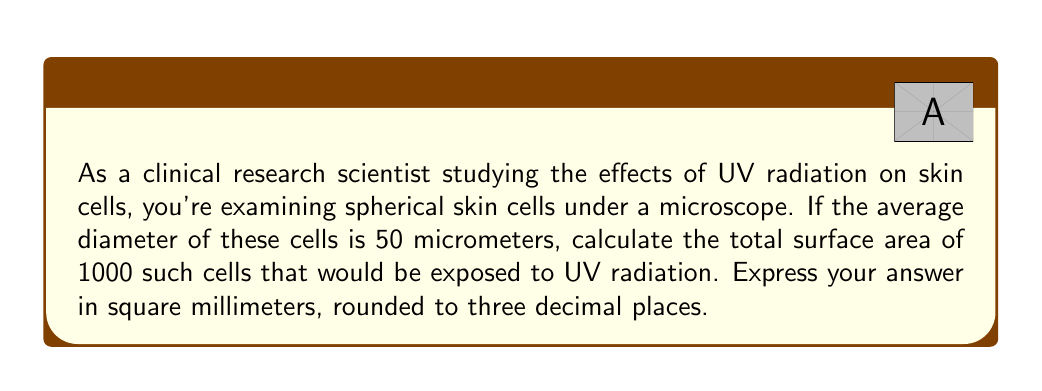Can you answer this question? To solve this problem, we need to follow these steps:

1. Calculate the radius of a single cell:
   The diameter is 50 micrometers, so the radius is half of that.
   $$r = \frac{50}{2} = 25 \text{ micrometers}$$

2. Calculate the surface area of a single spherical cell:
   The formula for the surface area of a sphere is $A = 4\pi r^2$
   $$A = 4\pi(25)^2 = 4\pi(625) = 2500\pi \text{ square micrometers}$$

3. Calculate the total surface area for 1000 cells:
   $$\text{Total Area} = 1000 \times 2500\pi = 2,500,000\pi \text{ square micrometers}$$

4. Convert square micrometers to square millimeters:
   1 millimeter = 1000 micrometers
   1 square millimeter = 1,000,000 square micrometers
   
   $$\text{Area in mm}^2 = \frac{2,500,000\pi}{1,000,000} = 2.5\pi \text{ mm}^2$$

5. Calculate the final result:
   $$2.5\pi \approx 7.853981634 \text{ mm}^2$$

6. Round to three decimal places:
   7.854 mm²
Answer: The total surface area of 1000 spherical skin cells exposed to UV radiation is approximately 7.854 mm². 